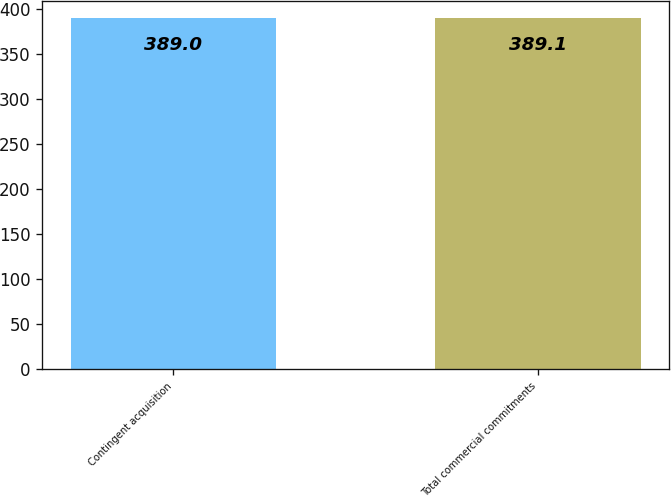<chart> <loc_0><loc_0><loc_500><loc_500><bar_chart><fcel>Contingent acquisition<fcel>Total commercial commitments<nl><fcel>389<fcel>389.1<nl></chart> 